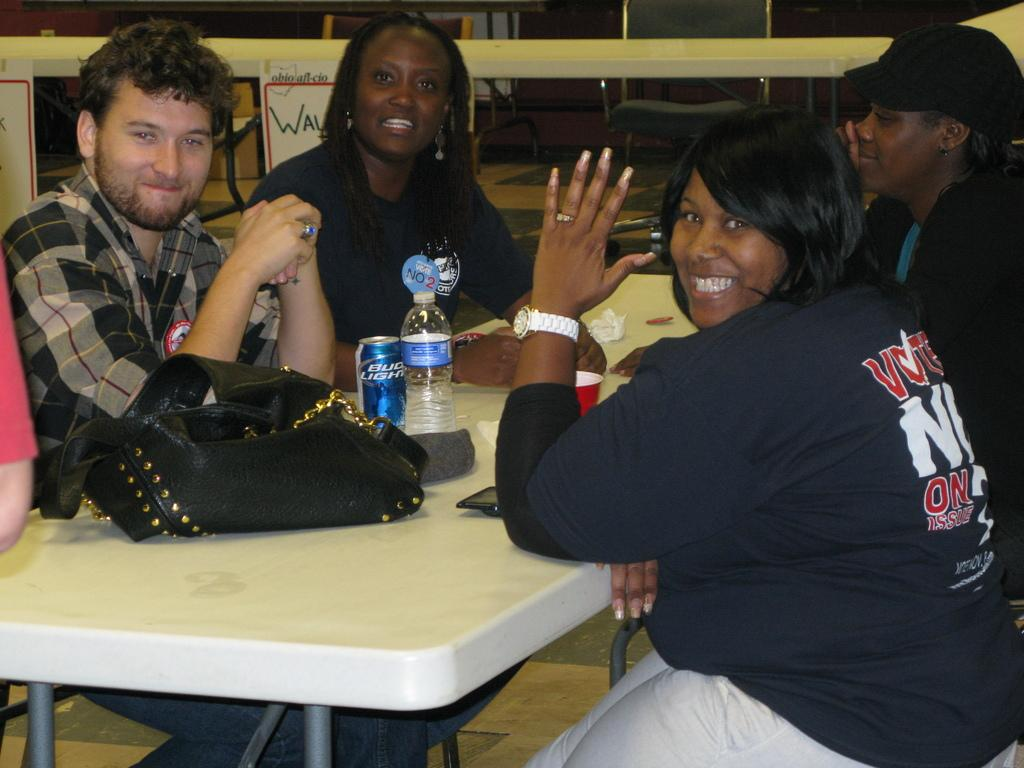How many people are sitting in the image? There are four people sitting on chairs in the image. What is the main piece of furniture in the image? There is a table in the image. What items can be seen on the table? A handbag, a water bottle, a paper, and a cup are on the table. Is there any furniture visible in the background? Yes, there is another table visible in the background. Are there any empty chairs in the image? Yes, there is an empty chair present in the background. Can you tell me how many friends are waving at the people in the image? There are no friends or waving people present in the image. Who is the owner of the handbag on the table? The image does not provide information about the ownership of the handbag, so it cannot be determined. 